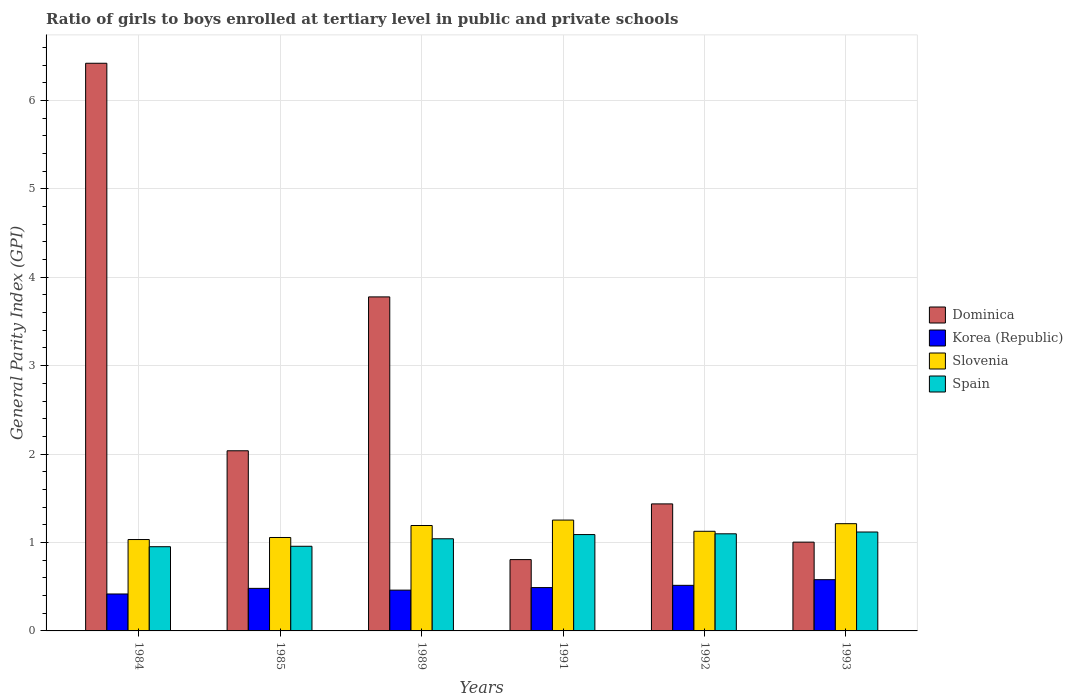How many groups of bars are there?
Offer a terse response. 6. Are the number of bars on each tick of the X-axis equal?
Provide a short and direct response. Yes. How many bars are there on the 5th tick from the left?
Offer a terse response. 4. What is the label of the 6th group of bars from the left?
Offer a terse response. 1993. In how many cases, is the number of bars for a given year not equal to the number of legend labels?
Your answer should be very brief. 0. What is the general parity index in Korea (Republic) in 1992?
Offer a very short reply. 0.52. Across all years, what is the maximum general parity index in Korea (Republic)?
Your response must be concise. 0.58. Across all years, what is the minimum general parity index in Korea (Republic)?
Your answer should be very brief. 0.42. In which year was the general parity index in Slovenia maximum?
Ensure brevity in your answer.  1991. In which year was the general parity index in Slovenia minimum?
Ensure brevity in your answer.  1984. What is the total general parity index in Korea (Republic) in the graph?
Ensure brevity in your answer.  2.95. What is the difference between the general parity index in Dominica in 1991 and that in 1993?
Provide a short and direct response. -0.2. What is the difference between the general parity index in Spain in 1992 and the general parity index in Korea (Republic) in 1984?
Offer a terse response. 0.68. What is the average general parity index in Dominica per year?
Offer a very short reply. 2.58. In the year 1991, what is the difference between the general parity index in Dominica and general parity index in Slovenia?
Your answer should be very brief. -0.45. In how many years, is the general parity index in Spain greater than 5.6?
Provide a succinct answer. 0. What is the ratio of the general parity index in Slovenia in 1984 to that in 1985?
Provide a succinct answer. 0.98. Is the general parity index in Korea (Republic) in 1984 less than that in 1992?
Give a very brief answer. Yes. What is the difference between the highest and the second highest general parity index in Spain?
Offer a terse response. 0.02. What is the difference between the highest and the lowest general parity index in Spain?
Provide a succinct answer. 0.17. Is the sum of the general parity index in Dominica in 1985 and 1992 greater than the maximum general parity index in Korea (Republic) across all years?
Ensure brevity in your answer.  Yes. Is it the case that in every year, the sum of the general parity index in Slovenia and general parity index in Korea (Republic) is greater than the sum of general parity index in Spain and general parity index in Dominica?
Your answer should be very brief. No. What does the 1st bar from the left in 1985 represents?
Your response must be concise. Dominica. What does the 4th bar from the right in 1984 represents?
Ensure brevity in your answer.  Dominica. What is the difference between two consecutive major ticks on the Y-axis?
Your answer should be compact. 1. Are the values on the major ticks of Y-axis written in scientific E-notation?
Ensure brevity in your answer.  No. What is the title of the graph?
Make the answer very short. Ratio of girls to boys enrolled at tertiary level in public and private schools. What is the label or title of the Y-axis?
Ensure brevity in your answer.  General Parity Index (GPI). What is the General Parity Index (GPI) of Dominica in 1984?
Your answer should be very brief. 6.42. What is the General Parity Index (GPI) of Korea (Republic) in 1984?
Ensure brevity in your answer.  0.42. What is the General Parity Index (GPI) in Slovenia in 1984?
Offer a terse response. 1.03. What is the General Parity Index (GPI) of Spain in 1984?
Offer a very short reply. 0.95. What is the General Parity Index (GPI) in Dominica in 1985?
Offer a very short reply. 2.04. What is the General Parity Index (GPI) of Korea (Republic) in 1985?
Offer a very short reply. 0.48. What is the General Parity Index (GPI) in Slovenia in 1985?
Provide a succinct answer. 1.06. What is the General Parity Index (GPI) of Spain in 1985?
Make the answer very short. 0.96. What is the General Parity Index (GPI) of Dominica in 1989?
Offer a very short reply. 3.78. What is the General Parity Index (GPI) in Korea (Republic) in 1989?
Your response must be concise. 0.46. What is the General Parity Index (GPI) of Slovenia in 1989?
Give a very brief answer. 1.19. What is the General Parity Index (GPI) of Spain in 1989?
Your answer should be compact. 1.04. What is the General Parity Index (GPI) in Dominica in 1991?
Ensure brevity in your answer.  0.81. What is the General Parity Index (GPI) of Korea (Republic) in 1991?
Your response must be concise. 0.49. What is the General Parity Index (GPI) in Slovenia in 1991?
Ensure brevity in your answer.  1.25. What is the General Parity Index (GPI) of Spain in 1991?
Your answer should be compact. 1.09. What is the General Parity Index (GPI) of Dominica in 1992?
Your response must be concise. 1.44. What is the General Parity Index (GPI) of Korea (Republic) in 1992?
Offer a terse response. 0.52. What is the General Parity Index (GPI) in Slovenia in 1992?
Make the answer very short. 1.13. What is the General Parity Index (GPI) of Spain in 1992?
Ensure brevity in your answer.  1.1. What is the General Parity Index (GPI) in Dominica in 1993?
Your answer should be compact. 1. What is the General Parity Index (GPI) in Korea (Republic) in 1993?
Your response must be concise. 0.58. What is the General Parity Index (GPI) in Slovenia in 1993?
Provide a succinct answer. 1.21. What is the General Parity Index (GPI) in Spain in 1993?
Offer a very short reply. 1.12. Across all years, what is the maximum General Parity Index (GPI) of Dominica?
Keep it short and to the point. 6.42. Across all years, what is the maximum General Parity Index (GPI) in Korea (Republic)?
Provide a succinct answer. 0.58. Across all years, what is the maximum General Parity Index (GPI) in Slovenia?
Provide a short and direct response. 1.25. Across all years, what is the maximum General Parity Index (GPI) in Spain?
Offer a very short reply. 1.12. Across all years, what is the minimum General Parity Index (GPI) in Dominica?
Give a very brief answer. 0.81. Across all years, what is the minimum General Parity Index (GPI) of Korea (Republic)?
Your answer should be very brief. 0.42. Across all years, what is the minimum General Parity Index (GPI) in Slovenia?
Your answer should be compact. 1.03. Across all years, what is the minimum General Parity Index (GPI) of Spain?
Your answer should be very brief. 0.95. What is the total General Parity Index (GPI) in Dominica in the graph?
Keep it short and to the point. 15.48. What is the total General Parity Index (GPI) in Korea (Republic) in the graph?
Make the answer very short. 2.95. What is the total General Parity Index (GPI) in Slovenia in the graph?
Provide a short and direct response. 6.88. What is the total General Parity Index (GPI) of Spain in the graph?
Your answer should be very brief. 6.26. What is the difference between the General Parity Index (GPI) of Dominica in 1984 and that in 1985?
Offer a very short reply. 4.38. What is the difference between the General Parity Index (GPI) of Korea (Republic) in 1984 and that in 1985?
Offer a terse response. -0.06. What is the difference between the General Parity Index (GPI) in Slovenia in 1984 and that in 1985?
Give a very brief answer. -0.02. What is the difference between the General Parity Index (GPI) in Spain in 1984 and that in 1985?
Keep it short and to the point. -0.01. What is the difference between the General Parity Index (GPI) of Dominica in 1984 and that in 1989?
Offer a very short reply. 2.64. What is the difference between the General Parity Index (GPI) in Korea (Republic) in 1984 and that in 1989?
Your answer should be compact. -0.04. What is the difference between the General Parity Index (GPI) of Slovenia in 1984 and that in 1989?
Ensure brevity in your answer.  -0.16. What is the difference between the General Parity Index (GPI) in Spain in 1984 and that in 1989?
Ensure brevity in your answer.  -0.09. What is the difference between the General Parity Index (GPI) of Dominica in 1984 and that in 1991?
Your answer should be compact. 5.61. What is the difference between the General Parity Index (GPI) of Korea (Republic) in 1984 and that in 1991?
Ensure brevity in your answer.  -0.07. What is the difference between the General Parity Index (GPI) of Slovenia in 1984 and that in 1991?
Your answer should be compact. -0.22. What is the difference between the General Parity Index (GPI) in Spain in 1984 and that in 1991?
Provide a short and direct response. -0.14. What is the difference between the General Parity Index (GPI) in Dominica in 1984 and that in 1992?
Ensure brevity in your answer.  4.98. What is the difference between the General Parity Index (GPI) in Korea (Republic) in 1984 and that in 1992?
Provide a short and direct response. -0.1. What is the difference between the General Parity Index (GPI) of Slovenia in 1984 and that in 1992?
Give a very brief answer. -0.09. What is the difference between the General Parity Index (GPI) of Spain in 1984 and that in 1992?
Provide a succinct answer. -0.15. What is the difference between the General Parity Index (GPI) in Dominica in 1984 and that in 1993?
Offer a very short reply. 5.42. What is the difference between the General Parity Index (GPI) of Korea (Republic) in 1984 and that in 1993?
Offer a terse response. -0.16. What is the difference between the General Parity Index (GPI) of Slovenia in 1984 and that in 1993?
Keep it short and to the point. -0.18. What is the difference between the General Parity Index (GPI) of Spain in 1984 and that in 1993?
Offer a terse response. -0.17. What is the difference between the General Parity Index (GPI) in Dominica in 1985 and that in 1989?
Provide a short and direct response. -1.74. What is the difference between the General Parity Index (GPI) in Korea (Republic) in 1985 and that in 1989?
Your response must be concise. 0.02. What is the difference between the General Parity Index (GPI) in Slovenia in 1985 and that in 1989?
Make the answer very short. -0.14. What is the difference between the General Parity Index (GPI) in Spain in 1985 and that in 1989?
Your answer should be compact. -0.08. What is the difference between the General Parity Index (GPI) in Dominica in 1985 and that in 1991?
Your response must be concise. 1.23. What is the difference between the General Parity Index (GPI) of Korea (Republic) in 1985 and that in 1991?
Your response must be concise. -0.01. What is the difference between the General Parity Index (GPI) of Slovenia in 1985 and that in 1991?
Provide a succinct answer. -0.2. What is the difference between the General Parity Index (GPI) in Spain in 1985 and that in 1991?
Ensure brevity in your answer.  -0.13. What is the difference between the General Parity Index (GPI) of Dominica in 1985 and that in 1992?
Make the answer very short. 0.6. What is the difference between the General Parity Index (GPI) of Korea (Republic) in 1985 and that in 1992?
Offer a very short reply. -0.03. What is the difference between the General Parity Index (GPI) of Slovenia in 1985 and that in 1992?
Your response must be concise. -0.07. What is the difference between the General Parity Index (GPI) in Spain in 1985 and that in 1992?
Offer a terse response. -0.14. What is the difference between the General Parity Index (GPI) of Dominica in 1985 and that in 1993?
Provide a succinct answer. 1.03. What is the difference between the General Parity Index (GPI) in Korea (Republic) in 1985 and that in 1993?
Make the answer very short. -0.1. What is the difference between the General Parity Index (GPI) of Slovenia in 1985 and that in 1993?
Your answer should be very brief. -0.16. What is the difference between the General Parity Index (GPI) of Spain in 1985 and that in 1993?
Your answer should be very brief. -0.16. What is the difference between the General Parity Index (GPI) of Dominica in 1989 and that in 1991?
Keep it short and to the point. 2.97. What is the difference between the General Parity Index (GPI) of Korea (Republic) in 1989 and that in 1991?
Provide a succinct answer. -0.03. What is the difference between the General Parity Index (GPI) of Slovenia in 1989 and that in 1991?
Provide a short and direct response. -0.06. What is the difference between the General Parity Index (GPI) of Spain in 1989 and that in 1991?
Your response must be concise. -0.05. What is the difference between the General Parity Index (GPI) in Dominica in 1989 and that in 1992?
Your answer should be compact. 2.34. What is the difference between the General Parity Index (GPI) of Korea (Republic) in 1989 and that in 1992?
Your answer should be very brief. -0.05. What is the difference between the General Parity Index (GPI) in Slovenia in 1989 and that in 1992?
Ensure brevity in your answer.  0.07. What is the difference between the General Parity Index (GPI) of Spain in 1989 and that in 1992?
Offer a very short reply. -0.06. What is the difference between the General Parity Index (GPI) in Dominica in 1989 and that in 1993?
Make the answer very short. 2.77. What is the difference between the General Parity Index (GPI) of Korea (Republic) in 1989 and that in 1993?
Make the answer very short. -0.12. What is the difference between the General Parity Index (GPI) in Slovenia in 1989 and that in 1993?
Your response must be concise. -0.02. What is the difference between the General Parity Index (GPI) of Spain in 1989 and that in 1993?
Offer a terse response. -0.08. What is the difference between the General Parity Index (GPI) in Dominica in 1991 and that in 1992?
Provide a succinct answer. -0.63. What is the difference between the General Parity Index (GPI) in Korea (Republic) in 1991 and that in 1992?
Keep it short and to the point. -0.03. What is the difference between the General Parity Index (GPI) of Slovenia in 1991 and that in 1992?
Provide a succinct answer. 0.13. What is the difference between the General Parity Index (GPI) of Spain in 1991 and that in 1992?
Offer a very short reply. -0.01. What is the difference between the General Parity Index (GPI) in Dominica in 1991 and that in 1993?
Keep it short and to the point. -0.2. What is the difference between the General Parity Index (GPI) of Korea (Republic) in 1991 and that in 1993?
Provide a succinct answer. -0.09. What is the difference between the General Parity Index (GPI) in Slovenia in 1991 and that in 1993?
Give a very brief answer. 0.04. What is the difference between the General Parity Index (GPI) of Spain in 1991 and that in 1993?
Make the answer very short. -0.03. What is the difference between the General Parity Index (GPI) in Dominica in 1992 and that in 1993?
Ensure brevity in your answer.  0.43. What is the difference between the General Parity Index (GPI) in Korea (Republic) in 1992 and that in 1993?
Give a very brief answer. -0.06. What is the difference between the General Parity Index (GPI) in Slovenia in 1992 and that in 1993?
Provide a succinct answer. -0.09. What is the difference between the General Parity Index (GPI) in Spain in 1992 and that in 1993?
Your answer should be very brief. -0.02. What is the difference between the General Parity Index (GPI) of Dominica in 1984 and the General Parity Index (GPI) of Korea (Republic) in 1985?
Give a very brief answer. 5.94. What is the difference between the General Parity Index (GPI) in Dominica in 1984 and the General Parity Index (GPI) in Slovenia in 1985?
Give a very brief answer. 5.36. What is the difference between the General Parity Index (GPI) of Dominica in 1984 and the General Parity Index (GPI) of Spain in 1985?
Keep it short and to the point. 5.46. What is the difference between the General Parity Index (GPI) of Korea (Republic) in 1984 and the General Parity Index (GPI) of Slovenia in 1985?
Your answer should be very brief. -0.64. What is the difference between the General Parity Index (GPI) of Korea (Republic) in 1984 and the General Parity Index (GPI) of Spain in 1985?
Make the answer very short. -0.54. What is the difference between the General Parity Index (GPI) in Slovenia in 1984 and the General Parity Index (GPI) in Spain in 1985?
Make the answer very short. 0.08. What is the difference between the General Parity Index (GPI) of Dominica in 1984 and the General Parity Index (GPI) of Korea (Republic) in 1989?
Your response must be concise. 5.96. What is the difference between the General Parity Index (GPI) in Dominica in 1984 and the General Parity Index (GPI) in Slovenia in 1989?
Make the answer very short. 5.23. What is the difference between the General Parity Index (GPI) in Dominica in 1984 and the General Parity Index (GPI) in Spain in 1989?
Ensure brevity in your answer.  5.38. What is the difference between the General Parity Index (GPI) of Korea (Republic) in 1984 and the General Parity Index (GPI) of Slovenia in 1989?
Your answer should be compact. -0.77. What is the difference between the General Parity Index (GPI) of Korea (Republic) in 1984 and the General Parity Index (GPI) of Spain in 1989?
Your answer should be very brief. -0.62. What is the difference between the General Parity Index (GPI) of Slovenia in 1984 and the General Parity Index (GPI) of Spain in 1989?
Give a very brief answer. -0.01. What is the difference between the General Parity Index (GPI) in Dominica in 1984 and the General Parity Index (GPI) in Korea (Republic) in 1991?
Your response must be concise. 5.93. What is the difference between the General Parity Index (GPI) of Dominica in 1984 and the General Parity Index (GPI) of Slovenia in 1991?
Make the answer very short. 5.17. What is the difference between the General Parity Index (GPI) in Dominica in 1984 and the General Parity Index (GPI) in Spain in 1991?
Offer a very short reply. 5.33. What is the difference between the General Parity Index (GPI) of Korea (Republic) in 1984 and the General Parity Index (GPI) of Slovenia in 1991?
Your response must be concise. -0.84. What is the difference between the General Parity Index (GPI) of Korea (Republic) in 1984 and the General Parity Index (GPI) of Spain in 1991?
Offer a terse response. -0.67. What is the difference between the General Parity Index (GPI) in Slovenia in 1984 and the General Parity Index (GPI) in Spain in 1991?
Provide a short and direct response. -0.06. What is the difference between the General Parity Index (GPI) of Dominica in 1984 and the General Parity Index (GPI) of Korea (Republic) in 1992?
Provide a short and direct response. 5.9. What is the difference between the General Parity Index (GPI) of Dominica in 1984 and the General Parity Index (GPI) of Slovenia in 1992?
Offer a very short reply. 5.29. What is the difference between the General Parity Index (GPI) of Dominica in 1984 and the General Parity Index (GPI) of Spain in 1992?
Your answer should be very brief. 5.32. What is the difference between the General Parity Index (GPI) in Korea (Republic) in 1984 and the General Parity Index (GPI) in Slovenia in 1992?
Ensure brevity in your answer.  -0.71. What is the difference between the General Parity Index (GPI) in Korea (Republic) in 1984 and the General Parity Index (GPI) in Spain in 1992?
Make the answer very short. -0.68. What is the difference between the General Parity Index (GPI) in Slovenia in 1984 and the General Parity Index (GPI) in Spain in 1992?
Your response must be concise. -0.06. What is the difference between the General Parity Index (GPI) of Dominica in 1984 and the General Parity Index (GPI) of Korea (Republic) in 1993?
Keep it short and to the point. 5.84. What is the difference between the General Parity Index (GPI) of Dominica in 1984 and the General Parity Index (GPI) of Slovenia in 1993?
Your response must be concise. 5.21. What is the difference between the General Parity Index (GPI) in Dominica in 1984 and the General Parity Index (GPI) in Spain in 1993?
Keep it short and to the point. 5.3. What is the difference between the General Parity Index (GPI) in Korea (Republic) in 1984 and the General Parity Index (GPI) in Slovenia in 1993?
Offer a very short reply. -0.8. What is the difference between the General Parity Index (GPI) in Korea (Republic) in 1984 and the General Parity Index (GPI) in Spain in 1993?
Offer a very short reply. -0.7. What is the difference between the General Parity Index (GPI) of Slovenia in 1984 and the General Parity Index (GPI) of Spain in 1993?
Ensure brevity in your answer.  -0.09. What is the difference between the General Parity Index (GPI) of Dominica in 1985 and the General Parity Index (GPI) of Korea (Republic) in 1989?
Your answer should be compact. 1.58. What is the difference between the General Parity Index (GPI) in Dominica in 1985 and the General Parity Index (GPI) in Slovenia in 1989?
Ensure brevity in your answer.  0.85. What is the difference between the General Parity Index (GPI) in Korea (Republic) in 1985 and the General Parity Index (GPI) in Slovenia in 1989?
Offer a very short reply. -0.71. What is the difference between the General Parity Index (GPI) in Korea (Republic) in 1985 and the General Parity Index (GPI) in Spain in 1989?
Provide a short and direct response. -0.56. What is the difference between the General Parity Index (GPI) of Slovenia in 1985 and the General Parity Index (GPI) of Spain in 1989?
Keep it short and to the point. 0.01. What is the difference between the General Parity Index (GPI) of Dominica in 1985 and the General Parity Index (GPI) of Korea (Republic) in 1991?
Your response must be concise. 1.55. What is the difference between the General Parity Index (GPI) in Dominica in 1985 and the General Parity Index (GPI) in Slovenia in 1991?
Offer a very short reply. 0.78. What is the difference between the General Parity Index (GPI) of Dominica in 1985 and the General Parity Index (GPI) of Spain in 1991?
Your answer should be compact. 0.95. What is the difference between the General Parity Index (GPI) in Korea (Republic) in 1985 and the General Parity Index (GPI) in Slovenia in 1991?
Make the answer very short. -0.77. What is the difference between the General Parity Index (GPI) of Korea (Republic) in 1985 and the General Parity Index (GPI) of Spain in 1991?
Offer a very short reply. -0.61. What is the difference between the General Parity Index (GPI) of Slovenia in 1985 and the General Parity Index (GPI) of Spain in 1991?
Provide a short and direct response. -0.03. What is the difference between the General Parity Index (GPI) in Dominica in 1985 and the General Parity Index (GPI) in Korea (Republic) in 1992?
Your answer should be compact. 1.52. What is the difference between the General Parity Index (GPI) in Dominica in 1985 and the General Parity Index (GPI) in Slovenia in 1992?
Ensure brevity in your answer.  0.91. What is the difference between the General Parity Index (GPI) of Dominica in 1985 and the General Parity Index (GPI) of Spain in 1992?
Keep it short and to the point. 0.94. What is the difference between the General Parity Index (GPI) in Korea (Republic) in 1985 and the General Parity Index (GPI) in Slovenia in 1992?
Provide a succinct answer. -0.65. What is the difference between the General Parity Index (GPI) in Korea (Republic) in 1985 and the General Parity Index (GPI) in Spain in 1992?
Give a very brief answer. -0.62. What is the difference between the General Parity Index (GPI) of Slovenia in 1985 and the General Parity Index (GPI) of Spain in 1992?
Your answer should be compact. -0.04. What is the difference between the General Parity Index (GPI) of Dominica in 1985 and the General Parity Index (GPI) of Korea (Republic) in 1993?
Provide a succinct answer. 1.46. What is the difference between the General Parity Index (GPI) in Dominica in 1985 and the General Parity Index (GPI) in Slovenia in 1993?
Offer a terse response. 0.82. What is the difference between the General Parity Index (GPI) in Dominica in 1985 and the General Parity Index (GPI) in Spain in 1993?
Your answer should be very brief. 0.92. What is the difference between the General Parity Index (GPI) in Korea (Republic) in 1985 and the General Parity Index (GPI) in Slovenia in 1993?
Ensure brevity in your answer.  -0.73. What is the difference between the General Parity Index (GPI) of Korea (Republic) in 1985 and the General Parity Index (GPI) of Spain in 1993?
Your response must be concise. -0.64. What is the difference between the General Parity Index (GPI) in Slovenia in 1985 and the General Parity Index (GPI) in Spain in 1993?
Make the answer very short. -0.06. What is the difference between the General Parity Index (GPI) in Dominica in 1989 and the General Parity Index (GPI) in Korea (Republic) in 1991?
Give a very brief answer. 3.29. What is the difference between the General Parity Index (GPI) in Dominica in 1989 and the General Parity Index (GPI) in Slovenia in 1991?
Make the answer very short. 2.52. What is the difference between the General Parity Index (GPI) in Dominica in 1989 and the General Parity Index (GPI) in Spain in 1991?
Your answer should be very brief. 2.69. What is the difference between the General Parity Index (GPI) in Korea (Republic) in 1989 and the General Parity Index (GPI) in Slovenia in 1991?
Offer a terse response. -0.79. What is the difference between the General Parity Index (GPI) of Korea (Republic) in 1989 and the General Parity Index (GPI) of Spain in 1991?
Your answer should be compact. -0.63. What is the difference between the General Parity Index (GPI) of Slovenia in 1989 and the General Parity Index (GPI) of Spain in 1991?
Your answer should be compact. 0.1. What is the difference between the General Parity Index (GPI) in Dominica in 1989 and the General Parity Index (GPI) in Korea (Republic) in 1992?
Offer a very short reply. 3.26. What is the difference between the General Parity Index (GPI) of Dominica in 1989 and the General Parity Index (GPI) of Slovenia in 1992?
Keep it short and to the point. 2.65. What is the difference between the General Parity Index (GPI) of Dominica in 1989 and the General Parity Index (GPI) of Spain in 1992?
Provide a succinct answer. 2.68. What is the difference between the General Parity Index (GPI) of Korea (Republic) in 1989 and the General Parity Index (GPI) of Slovenia in 1992?
Provide a succinct answer. -0.67. What is the difference between the General Parity Index (GPI) of Korea (Republic) in 1989 and the General Parity Index (GPI) of Spain in 1992?
Offer a terse response. -0.64. What is the difference between the General Parity Index (GPI) of Slovenia in 1989 and the General Parity Index (GPI) of Spain in 1992?
Your answer should be compact. 0.09. What is the difference between the General Parity Index (GPI) in Dominica in 1989 and the General Parity Index (GPI) in Korea (Republic) in 1993?
Offer a very short reply. 3.2. What is the difference between the General Parity Index (GPI) in Dominica in 1989 and the General Parity Index (GPI) in Slovenia in 1993?
Make the answer very short. 2.56. What is the difference between the General Parity Index (GPI) of Dominica in 1989 and the General Parity Index (GPI) of Spain in 1993?
Keep it short and to the point. 2.66. What is the difference between the General Parity Index (GPI) of Korea (Republic) in 1989 and the General Parity Index (GPI) of Slovenia in 1993?
Make the answer very short. -0.75. What is the difference between the General Parity Index (GPI) of Korea (Republic) in 1989 and the General Parity Index (GPI) of Spain in 1993?
Provide a succinct answer. -0.66. What is the difference between the General Parity Index (GPI) of Slovenia in 1989 and the General Parity Index (GPI) of Spain in 1993?
Give a very brief answer. 0.07. What is the difference between the General Parity Index (GPI) in Dominica in 1991 and the General Parity Index (GPI) in Korea (Republic) in 1992?
Provide a succinct answer. 0.29. What is the difference between the General Parity Index (GPI) of Dominica in 1991 and the General Parity Index (GPI) of Slovenia in 1992?
Offer a terse response. -0.32. What is the difference between the General Parity Index (GPI) in Dominica in 1991 and the General Parity Index (GPI) in Spain in 1992?
Offer a very short reply. -0.29. What is the difference between the General Parity Index (GPI) in Korea (Republic) in 1991 and the General Parity Index (GPI) in Slovenia in 1992?
Ensure brevity in your answer.  -0.64. What is the difference between the General Parity Index (GPI) of Korea (Republic) in 1991 and the General Parity Index (GPI) of Spain in 1992?
Offer a very short reply. -0.61. What is the difference between the General Parity Index (GPI) in Slovenia in 1991 and the General Parity Index (GPI) in Spain in 1992?
Your response must be concise. 0.16. What is the difference between the General Parity Index (GPI) in Dominica in 1991 and the General Parity Index (GPI) in Korea (Republic) in 1993?
Offer a very short reply. 0.23. What is the difference between the General Parity Index (GPI) in Dominica in 1991 and the General Parity Index (GPI) in Slovenia in 1993?
Ensure brevity in your answer.  -0.41. What is the difference between the General Parity Index (GPI) of Dominica in 1991 and the General Parity Index (GPI) of Spain in 1993?
Offer a very short reply. -0.31. What is the difference between the General Parity Index (GPI) of Korea (Republic) in 1991 and the General Parity Index (GPI) of Slovenia in 1993?
Your answer should be very brief. -0.72. What is the difference between the General Parity Index (GPI) of Korea (Republic) in 1991 and the General Parity Index (GPI) of Spain in 1993?
Keep it short and to the point. -0.63. What is the difference between the General Parity Index (GPI) of Slovenia in 1991 and the General Parity Index (GPI) of Spain in 1993?
Provide a short and direct response. 0.13. What is the difference between the General Parity Index (GPI) in Dominica in 1992 and the General Parity Index (GPI) in Slovenia in 1993?
Provide a short and direct response. 0.22. What is the difference between the General Parity Index (GPI) of Dominica in 1992 and the General Parity Index (GPI) of Spain in 1993?
Your answer should be very brief. 0.32. What is the difference between the General Parity Index (GPI) in Korea (Republic) in 1992 and the General Parity Index (GPI) in Slovenia in 1993?
Your answer should be compact. -0.7. What is the difference between the General Parity Index (GPI) in Korea (Republic) in 1992 and the General Parity Index (GPI) in Spain in 1993?
Provide a succinct answer. -0.6. What is the difference between the General Parity Index (GPI) of Slovenia in 1992 and the General Parity Index (GPI) of Spain in 1993?
Provide a short and direct response. 0.01. What is the average General Parity Index (GPI) of Dominica per year?
Keep it short and to the point. 2.58. What is the average General Parity Index (GPI) of Korea (Republic) per year?
Your answer should be compact. 0.49. What is the average General Parity Index (GPI) of Slovenia per year?
Your response must be concise. 1.15. What is the average General Parity Index (GPI) in Spain per year?
Give a very brief answer. 1.04. In the year 1984, what is the difference between the General Parity Index (GPI) in Dominica and General Parity Index (GPI) in Korea (Republic)?
Your answer should be compact. 6. In the year 1984, what is the difference between the General Parity Index (GPI) in Dominica and General Parity Index (GPI) in Slovenia?
Provide a short and direct response. 5.39. In the year 1984, what is the difference between the General Parity Index (GPI) in Dominica and General Parity Index (GPI) in Spain?
Your answer should be very brief. 5.47. In the year 1984, what is the difference between the General Parity Index (GPI) of Korea (Republic) and General Parity Index (GPI) of Slovenia?
Your answer should be compact. -0.62. In the year 1984, what is the difference between the General Parity Index (GPI) in Korea (Republic) and General Parity Index (GPI) in Spain?
Make the answer very short. -0.53. In the year 1984, what is the difference between the General Parity Index (GPI) of Slovenia and General Parity Index (GPI) of Spain?
Make the answer very short. 0.08. In the year 1985, what is the difference between the General Parity Index (GPI) of Dominica and General Parity Index (GPI) of Korea (Republic)?
Make the answer very short. 1.56. In the year 1985, what is the difference between the General Parity Index (GPI) in Dominica and General Parity Index (GPI) in Slovenia?
Provide a short and direct response. 0.98. In the year 1985, what is the difference between the General Parity Index (GPI) of Dominica and General Parity Index (GPI) of Spain?
Your answer should be very brief. 1.08. In the year 1985, what is the difference between the General Parity Index (GPI) of Korea (Republic) and General Parity Index (GPI) of Slovenia?
Offer a very short reply. -0.58. In the year 1985, what is the difference between the General Parity Index (GPI) of Korea (Republic) and General Parity Index (GPI) of Spain?
Your response must be concise. -0.48. In the year 1985, what is the difference between the General Parity Index (GPI) in Slovenia and General Parity Index (GPI) in Spain?
Provide a short and direct response. 0.1. In the year 1989, what is the difference between the General Parity Index (GPI) in Dominica and General Parity Index (GPI) in Korea (Republic)?
Provide a succinct answer. 3.32. In the year 1989, what is the difference between the General Parity Index (GPI) in Dominica and General Parity Index (GPI) in Slovenia?
Provide a short and direct response. 2.59. In the year 1989, what is the difference between the General Parity Index (GPI) in Dominica and General Parity Index (GPI) in Spain?
Offer a terse response. 2.74. In the year 1989, what is the difference between the General Parity Index (GPI) in Korea (Republic) and General Parity Index (GPI) in Slovenia?
Your answer should be compact. -0.73. In the year 1989, what is the difference between the General Parity Index (GPI) in Korea (Republic) and General Parity Index (GPI) in Spain?
Your response must be concise. -0.58. In the year 1991, what is the difference between the General Parity Index (GPI) in Dominica and General Parity Index (GPI) in Korea (Republic)?
Provide a succinct answer. 0.32. In the year 1991, what is the difference between the General Parity Index (GPI) of Dominica and General Parity Index (GPI) of Slovenia?
Ensure brevity in your answer.  -0.45. In the year 1991, what is the difference between the General Parity Index (GPI) of Dominica and General Parity Index (GPI) of Spain?
Give a very brief answer. -0.28. In the year 1991, what is the difference between the General Parity Index (GPI) of Korea (Republic) and General Parity Index (GPI) of Slovenia?
Your answer should be very brief. -0.76. In the year 1991, what is the difference between the General Parity Index (GPI) in Korea (Republic) and General Parity Index (GPI) in Spain?
Provide a succinct answer. -0.6. In the year 1991, what is the difference between the General Parity Index (GPI) of Slovenia and General Parity Index (GPI) of Spain?
Ensure brevity in your answer.  0.16. In the year 1992, what is the difference between the General Parity Index (GPI) of Dominica and General Parity Index (GPI) of Korea (Republic)?
Provide a succinct answer. 0.92. In the year 1992, what is the difference between the General Parity Index (GPI) in Dominica and General Parity Index (GPI) in Slovenia?
Provide a short and direct response. 0.31. In the year 1992, what is the difference between the General Parity Index (GPI) of Dominica and General Parity Index (GPI) of Spain?
Keep it short and to the point. 0.34. In the year 1992, what is the difference between the General Parity Index (GPI) in Korea (Republic) and General Parity Index (GPI) in Slovenia?
Offer a terse response. -0.61. In the year 1992, what is the difference between the General Parity Index (GPI) in Korea (Republic) and General Parity Index (GPI) in Spain?
Offer a very short reply. -0.58. In the year 1992, what is the difference between the General Parity Index (GPI) in Slovenia and General Parity Index (GPI) in Spain?
Provide a short and direct response. 0.03. In the year 1993, what is the difference between the General Parity Index (GPI) of Dominica and General Parity Index (GPI) of Korea (Republic)?
Offer a terse response. 0.42. In the year 1993, what is the difference between the General Parity Index (GPI) of Dominica and General Parity Index (GPI) of Slovenia?
Ensure brevity in your answer.  -0.21. In the year 1993, what is the difference between the General Parity Index (GPI) in Dominica and General Parity Index (GPI) in Spain?
Offer a very short reply. -0.11. In the year 1993, what is the difference between the General Parity Index (GPI) in Korea (Republic) and General Parity Index (GPI) in Slovenia?
Make the answer very short. -0.63. In the year 1993, what is the difference between the General Parity Index (GPI) of Korea (Republic) and General Parity Index (GPI) of Spain?
Keep it short and to the point. -0.54. In the year 1993, what is the difference between the General Parity Index (GPI) of Slovenia and General Parity Index (GPI) of Spain?
Give a very brief answer. 0.09. What is the ratio of the General Parity Index (GPI) of Dominica in 1984 to that in 1985?
Make the answer very short. 3.15. What is the ratio of the General Parity Index (GPI) of Korea (Republic) in 1984 to that in 1985?
Your answer should be very brief. 0.87. What is the ratio of the General Parity Index (GPI) in Slovenia in 1984 to that in 1985?
Offer a terse response. 0.98. What is the ratio of the General Parity Index (GPI) in Dominica in 1984 to that in 1989?
Offer a terse response. 1.7. What is the ratio of the General Parity Index (GPI) of Korea (Republic) in 1984 to that in 1989?
Make the answer very short. 0.91. What is the ratio of the General Parity Index (GPI) of Slovenia in 1984 to that in 1989?
Give a very brief answer. 0.87. What is the ratio of the General Parity Index (GPI) of Spain in 1984 to that in 1989?
Provide a succinct answer. 0.91. What is the ratio of the General Parity Index (GPI) of Dominica in 1984 to that in 1991?
Offer a terse response. 7.96. What is the ratio of the General Parity Index (GPI) of Korea (Republic) in 1984 to that in 1991?
Your answer should be compact. 0.85. What is the ratio of the General Parity Index (GPI) in Slovenia in 1984 to that in 1991?
Offer a terse response. 0.82. What is the ratio of the General Parity Index (GPI) in Spain in 1984 to that in 1991?
Your answer should be very brief. 0.87. What is the ratio of the General Parity Index (GPI) in Dominica in 1984 to that in 1992?
Your response must be concise. 4.47. What is the ratio of the General Parity Index (GPI) of Korea (Republic) in 1984 to that in 1992?
Offer a very short reply. 0.81. What is the ratio of the General Parity Index (GPI) in Slovenia in 1984 to that in 1992?
Give a very brief answer. 0.92. What is the ratio of the General Parity Index (GPI) of Spain in 1984 to that in 1992?
Provide a succinct answer. 0.87. What is the ratio of the General Parity Index (GPI) in Dominica in 1984 to that in 1993?
Offer a terse response. 6.39. What is the ratio of the General Parity Index (GPI) in Korea (Republic) in 1984 to that in 1993?
Offer a very short reply. 0.72. What is the ratio of the General Parity Index (GPI) in Slovenia in 1984 to that in 1993?
Give a very brief answer. 0.85. What is the ratio of the General Parity Index (GPI) in Spain in 1984 to that in 1993?
Offer a very short reply. 0.85. What is the ratio of the General Parity Index (GPI) in Dominica in 1985 to that in 1989?
Give a very brief answer. 0.54. What is the ratio of the General Parity Index (GPI) of Korea (Republic) in 1985 to that in 1989?
Offer a very short reply. 1.04. What is the ratio of the General Parity Index (GPI) in Slovenia in 1985 to that in 1989?
Offer a very short reply. 0.89. What is the ratio of the General Parity Index (GPI) in Spain in 1985 to that in 1989?
Provide a short and direct response. 0.92. What is the ratio of the General Parity Index (GPI) of Dominica in 1985 to that in 1991?
Offer a terse response. 2.53. What is the ratio of the General Parity Index (GPI) in Korea (Republic) in 1985 to that in 1991?
Provide a succinct answer. 0.98. What is the ratio of the General Parity Index (GPI) of Slovenia in 1985 to that in 1991?
Provide a succinct answer. 0.84. What is the ratio of the General Parity Index (GPI) of Spain in 1985 to that in 1991?
Your answer should be compact. 0.88. What is the ratio of the General Parity Index (GPI) in Dominica in 1985 to that in 1992?
Your answer should be compact. 1.42. What is the ratio of the General Parity Index (GPI) in Korea (Republic) in 1985 to that in 1992?
Your answer should be very brief. 0.93. What is the ratio of the General Parity Index (GPI) in Slovenia in 1985 to that in 1992?
Your answer should be very brief. 0.94. What is the ratio of the General Parity Index (GPI) in Spain in 1985 to that in 1992?
Make the answer very short. 0.87. What is the ratio of the General Parity Index (GPI) in Dominica in 1985 to that in 1993?
Provide a succinct answer. 2.03. What is the ratio of the General Parity Index (GPI) of Korea (Republic) in 1985 to that in 1993?
Ensure brevity in your answer.  0.83. What is the ratio of the General Parity Index (GPI) in Slovenia in 1985 to that in 1993?
Make the answer very short. 0.87. What is the ratio of the General Parity Index (GPI) in Spain in 1985 to that in 1993?
Provide a short and direct response. 0.86. What is the ratio of the General Parity Index (GPI) in Dominica in 1989 to that in 1991?
Offer a terse response. 4.68. What is the ratio of the General Parity Index (GPI) in Korea (Republic) in 1989 to that in 1991?
Your response must be concise. 0.94. What is the ratio of the General Parity Index (GPI) in Slovenia in 1989 to that in 1991?
Ensure brevity in your answer.  0.95. What is the ratio of the General Parity Index (GPI) in Spain in 1989 to that in 1991?
Your answer should be compact. 0.96. What is the ratio of the General Parity Index (GPI) of Dominica in 1989 to that in 1992?
Provide a short and direct response. 2.63. What is the ratio of the General Parity Index (GPI) in Korea (Republic) in 1989 to that in 1992?
Ensure brevity in your answer.  0.89. What is the ratio of the General Parity Index (GPI) of Slovenia in 1989 to that in 1992?
Provide a succinct answer. 1.06. What is the ratio of the General Parity Index (GPI) of Spain in 1989 to that in 1992?
Ensure brevity in your answer.  0.95. What is the ratio of the General Parity Index (GPI) in Dominica in 1989 to that in 1993?
Give a very brief answer. 3.76. What is the ratio of the General Parity Index (GPI) of Korea (Republic) in 1989 to that in 1993?
Offer a terse response. 0.8. What is the ratio of the General Parity Index (GPI) in Slovenia in 1989 to that in 1993?
Ensure brevity in your answer.  0.98. What is the ratio of the General Parity Index (GPI) of Spain in 1989 to that in 1993?
Your answer should be very brief. 0.93. What is the ratio of the General Parity Index (GPI) of Dominica in 1991 to that in 1992?
Ensure brevity in your answer.  0.56. What is the ratio of the General Parity Index (GPI) in Korea (Republic) in 1991 to that in 1992?
Offer a very short reply. 0.95. What is the ratio of the General Parity Index (GPI) in Slovenia in 1991 to that in 1992?
Your response must be concise. 1.11. What is the ratio of the General Parity Index (GPI) of Spain in 1991 to that in 1992?
Give a very brief answer. 0.99. What is the ratio of the General Parity Index (GPI) of Dominica in 1991 to that in 1993?
Give a very brief answer. 0.8. What is the ratio of the General Parity Index (GPI) of Korea (Republic) in 1991 to that in 1993?
Your response must be concise. 0.85. What is the ratio of the General Parity Index (GPI) in Slovenia in 1991 to that in 1993?
Your answer should be compact. 1.03. What is the ratio of the General Parity Index (GPI) in Spain in 1991 to that in 1993?
Make the answer very short. 0.97. What is the ratio of the General Parity Index (GPI) in Dominica in 1992 to that in 1993?
Ensure brevity in your answer.  1.43. What is the ratio of the General Parity Index (GPI) in Korea (Republic) in 1992 to that in 1993?
Your response must be concise. 0.89. What is the ratio of the General Parity Index (GPI) in Slovenia in 1992 to that in 1993?
Keep it short and to the point. 0.93. What is the ratio of the General Parity Index (GPI) of Spain in 1992 to that in 1993?
Keep it short and to the point. 0.98. What is the difference between the highest and the second highest General Parity Index (GPI) of Dominica?
Keep it short and to the point. 2.64. What is the difference between the highest and the second highest General Parity Index (GPI) in Korea (Republic)?
Give a very brief answer. 0.06. What is the difference between the highest and the second highest General Parity Index (GPI) of Slovenia?
Provide a short and direct response. 0.04. What is the difference between the highest and the second highest General Parity Index (GPI) of Spain?
Your answer should be very brief. 0.02. What is the difference between the highest and the lowest General Parity Index (GPI) in Dominica?
Keep it short and to the point. 5.61. What is the difference between the highest and the lowest General Parity Index (GPI) of Korea (Republic)?
Provide a short and direct response. 0.16. What is the difference between the highest and the lowest General Parity Index (GPI) in Slovenia?
Make the answer very short. 0.22. What is the difference between the highest and the lowest General Parity Index (GPI) in Spain?
Make the answer very short. 0.17. 